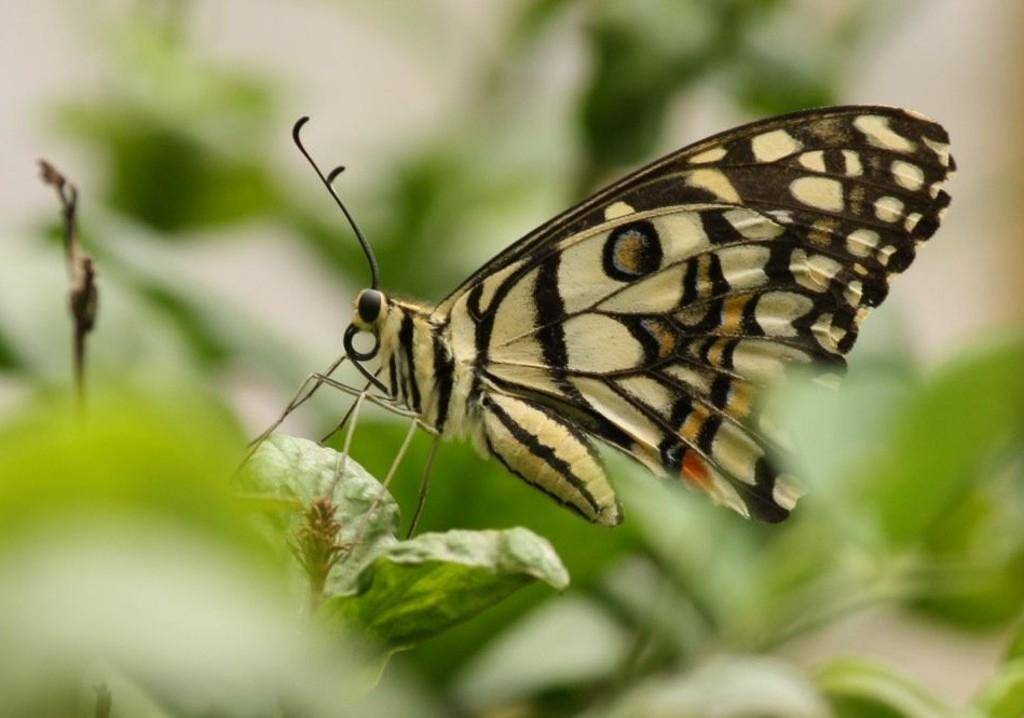What is the main subject of the image? There is a butterfly in the image. Where is the butterfly located? The butterfly is on a leaf. What else can be seen in the image besides the butterfly? There are leaves visible in the background of the image. What type of rhythm can be heard coming from the butterfly in the image? There is no sound or rhythm associated with the butterfly in the image. 